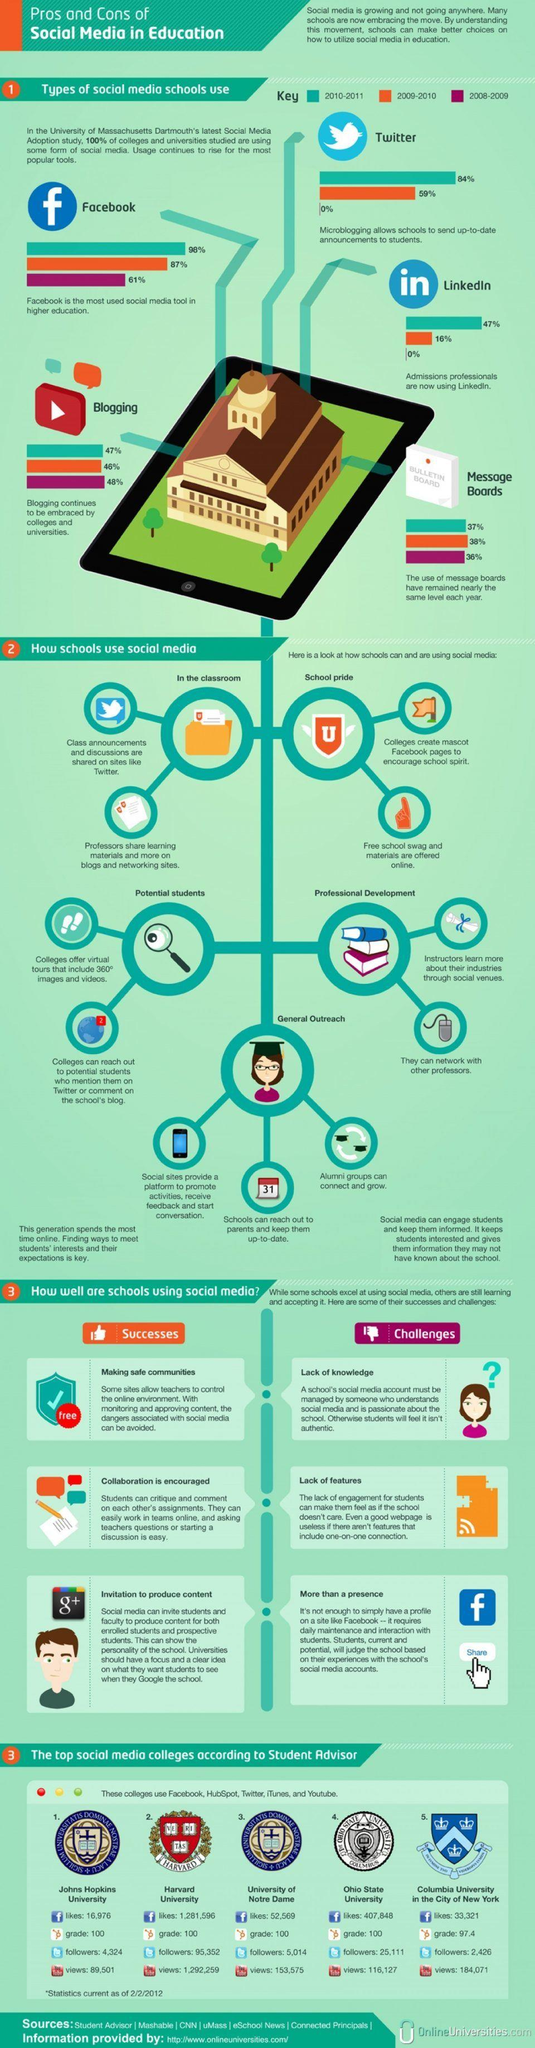List a handful of essential elements in this visual. During the period of 2008-2009, Twitter and LinkedIn were the least used social media tools. Harvard University has 95,352 followers on Twitter. According to data collected in the year 2010-2011, Facebook was the most commonly used social media tool among schools. The number of Facebook likes for Columbia University is 33,321. According to data collected from 2008 to 2011, the average percentage of use of message boards by schools was 37%. 